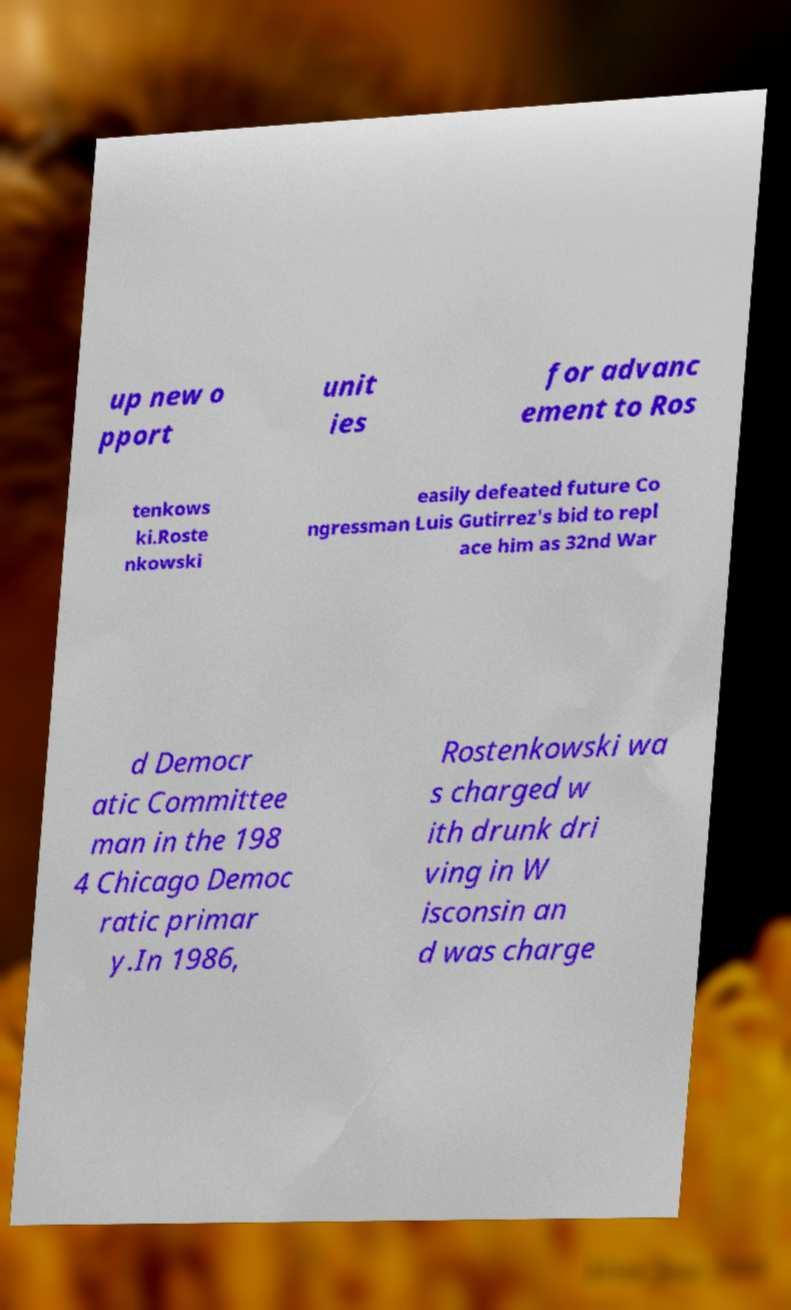I need the written content from this picture converted into text. Can you do that? up new o pport unit ies for advanc ement to Ros tenkows ki.Roste nkowski easily defeated future Co ngressman Luis Gutirrez's bid to repl ace him as 32nd War d Democr atic Committee man in the 198 4 Chicago Democ ratic primar y.In 1986, Rostenkowski wa s charged w ith drunk dri ving in W isconsin an d was charge 